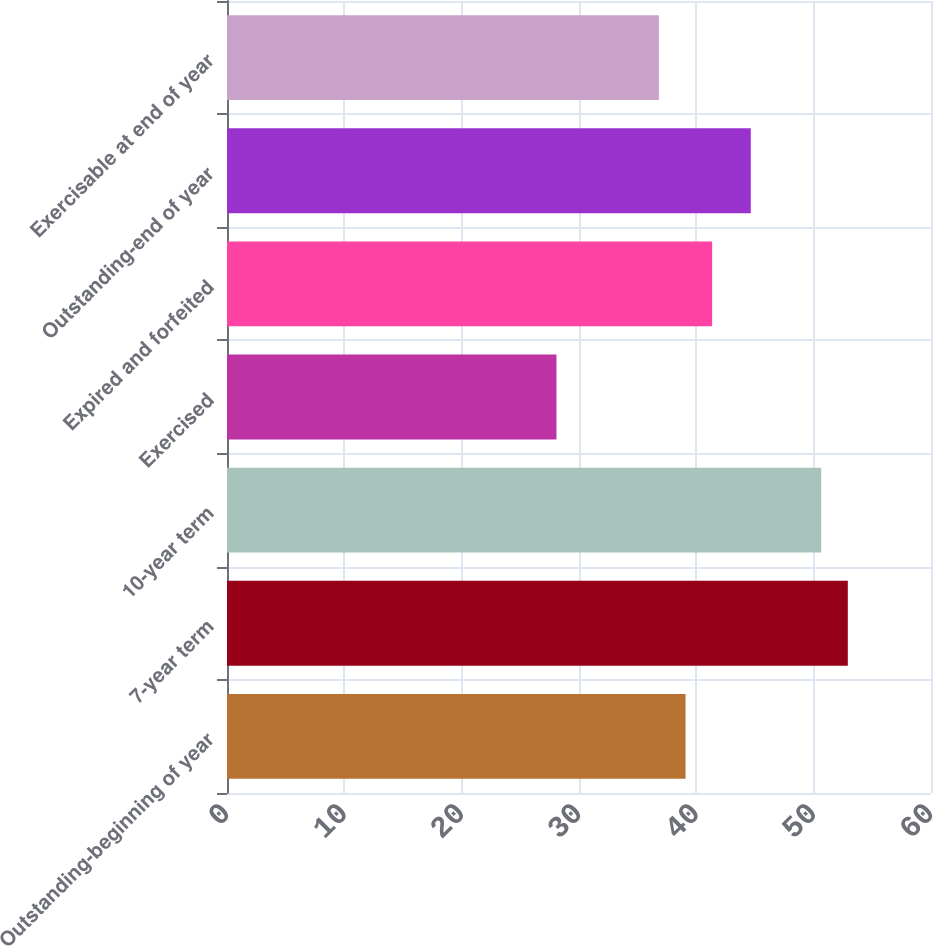<chart> <loc_0><loc_0><loc_500><loc_500><bar_chart><fcel>Outstanding-beginning of year<fcel>7-year term<fcel>10-year term<fcel>Exercised<fcel>Expired and forfeited<fcel>Outstanding-end of year<fcel>Exercisable at end of year<nl><fcel>39.08<fcel>52.91<fcel>50.64<fcel>28.08<fcel>41.35<fcel>44.64<fcel>36.81<nl></chart> 